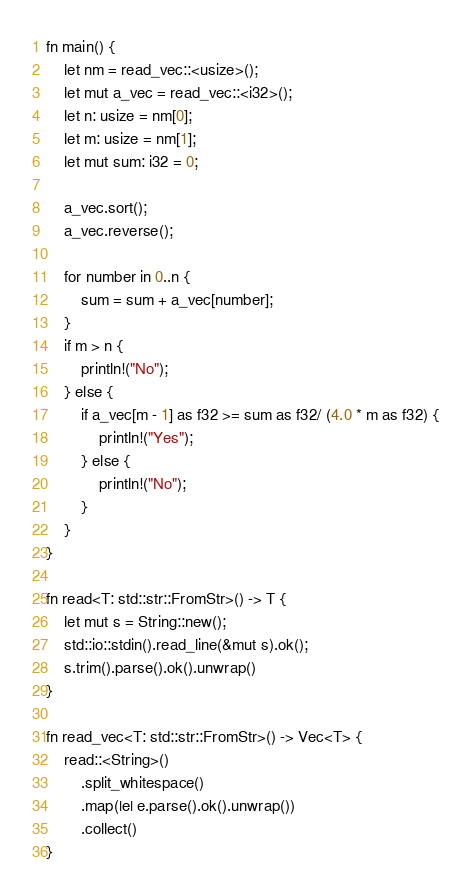Convert code to text. <code><loc_0><loc_0><loc_500><loc_500><_Rust_>fn main() {
    let nm = read_vec::<usize>();
    let mut a_vec = read_vec::<i32>();
    let n: usize = nm[0];
    let m: usize = nm[1];
    let mut sum: i32 = 0;

    a_vec.sort();
    a_vec.reverse();

    for number in 0..n {
        sum = sum + a_vec[number];
    }
    if m > n {
        println!("No");
    } else {
        if a_vec[m - 1] as f32 >= sum as f32/ (4.0 * m as f32) {
            println!("Yes");
        } else {
            println!("No");
        }
    }
}

fn read<T: std::str::FromStr>() -> T {
    let mut s = String::new();
    std::io::stdin().read_line(&mut s).ok();
    s.trim().parse().ok().unwrap()
}

fn read_vec<T: std::str::FromStr>() -> Vec<T> {
    read::<String>()
        .split_whitespace()
        .map(|e| e.parse().ok().unwrap())
        .collect()
}
</code> 